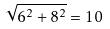<formula> <loc_0><loc_0><loc_500><loc_500>\sqrt { 6 ^ { 2 } + 8 ^ { 2 } } = 1 0</formula> 